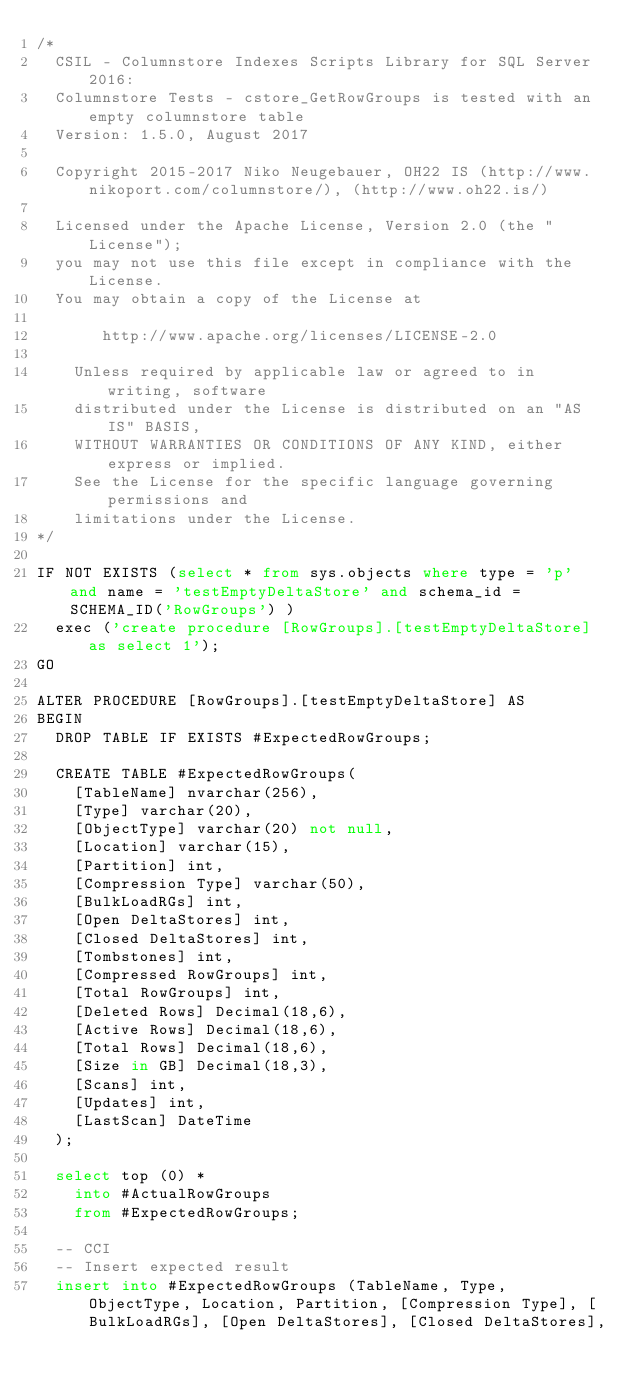Convert code to text. <code><loc_0><loc_0><loc_500><loc_500><_SQL_>/*
	CSIL - Columnstore Indexes Scripts Library for SQL Server 2016: 
	Columnstore Tests - cstore_GetRowGroups is tested with an empty columnstore table 
	Version: 1.5.0, August 2017

	Copyright 2015-2017 Niko Neugebauer, OH22 IS (http://www.nikoport.com/columnstore/), (http://www.oh22.is/)

	Licensed under the Apache License, Version 2.0 (the "License");
	you may not use this file except in compliance with the License.
	You may obtain a copy of the License at

       http://www.apache.org/licenses/LICENSE-2.0

    Unless required by applicable law or agreed to in writing, software
    distributed under the License is distributed on an "AS IS" BASIS,
    WITHOUT WARRANTIES OR CONDITIONS OF ANY KIND, either express or implied.
    See the License for the specific language governing permissions and
    limitations under the License.
*/

IF NOT EXISTS (select * from sys.objects where type = 'p' and name = 'testEmptyDeltaStore' and schema_id = SCHEMA_ID('RowGroups') )
	exec ('create procedure [RowGroups].[testEmptyDeltaStore] as select 1');
GO

ALTER PROCEDURE [RowGroups].[testEmptyDeltaStore] AS
BEGIN
	DROP TABLE IF EXISTS #ExpectedRowGroups;

	CREATE TABLE #ExpectedRowGroups(
		[TableName] nvarchar(256),
		[Type] varchar(20),
		[ObjectType] varchar(20) not null,
		[Location] varchar(15),
		[Partition] int,
		[Compression Type] varchar(50),
		[BulkLoadRGs] int,
		[Open DeltaStores] int,
		[Closed DeltaStores] int,
		[Tombstones] int,
		[Compressed RowGroups] int,
		[Total RowGroups] int,
		[Deleted Rows] Decimal(18,6),
		[Active Rows] Decimal(18,6),
		[Total Rows] Decimal(18,6),
		[Size in GB] Decimal(18,3),
		[Scans] int,
		[Updates] int,
		[LastScan] DateTime
	);

	select top (0) *
		into #ActualRowGroups
		from #ExpectedRowGroups;

	-- CCI
	-- Insert expected result
	insert into #ExpectedRowGroups (TableName, Type, ObjectType, Location, Partition, [Compression Type], [BulkLoadRGs], [Open DeltaStores], [Closed DeltaStores],</code> 